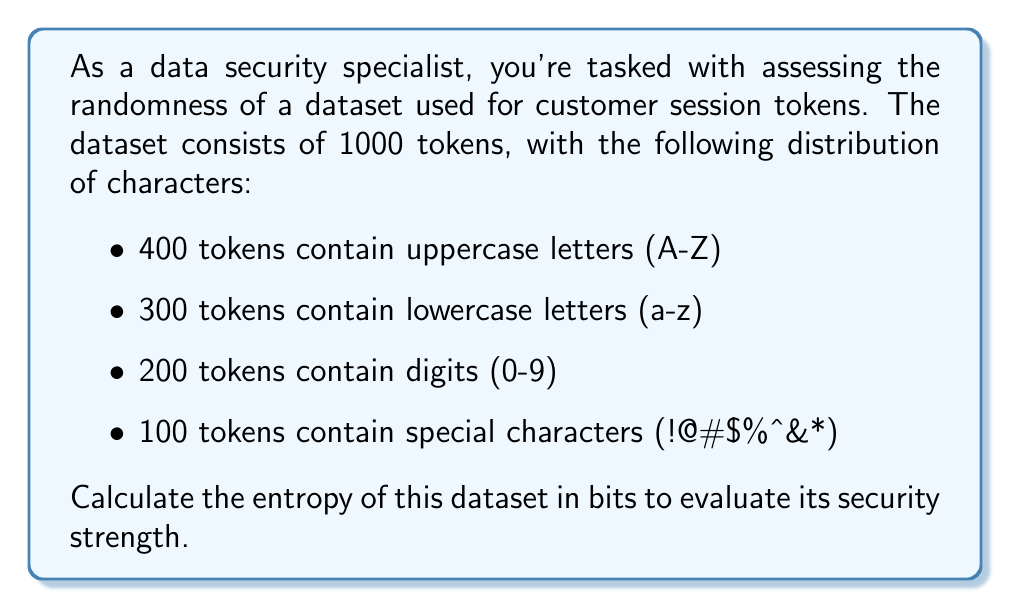Give your solution to this math problem. To calculate the entropy of the dataset, we'll use the formula:

$$H = -\sum_{i=1}^{n} p_i \log_2(p_i)$$

Where:
$H$ is the entropy in bits
$p_i$ is the probability of each event
$n$ is the number of possible events

Step 1: Calculate the probabilities for each character type:
- $p_{uppercase} = 400/1000 = 0.4$
- $p_{lowercase} = 300/1000 = 0.3$
- $p_{digits} = 200/1000 = 0.2$
- $p_{special} = 100/1000 = 0.1$

Step 2: Apply the entropy formula:

$$\begin{align}
H &= -[0.4 \log_2(0.4) + 0.3 \log_2(0.3) + 0.2 \log_2(0.2) + 0.1 \log_2(0.1)] \\
&= -[0.4 \cdot (-1.32) + 0.3 \cdot (-1.74) + 0.2 \cdot (-2.32) + 0.1 \cdot (-3.32)] \\
&= -[-0.528 - 0.522 - 0.464 - 0.332] \\
&= 1.846 \text{ bits}
\end{align}$$

Step 3: Interpret the result:
The calculated entropy of 1.846 bits indicates the average amount of information contained in each token. A higher entropy value suggests greater randomness and, consequently, better security strength.
Answer: 1.846 bits 